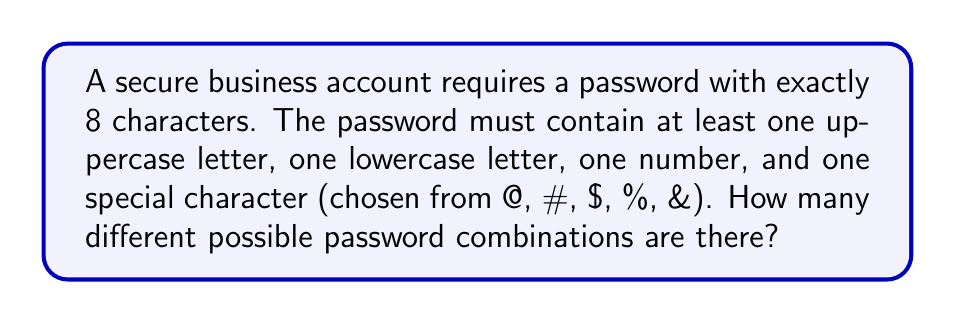Give your solution to this math problem. Let's break this down step-by-step:

1) First, we need to calculate the number of choices for each character:
   - Uppercase letters: 26
   - Lowercase letters: 26
   - Numbers: 10
   - Special characters: 5 (@, #, $, %, &)
   
   Total choices per character: $26 + 26 + 10 + 5 = 67$

2) Now, we need to ensure we have at least one of each required type. We can do this by choosing positions for these required characters:

   $\binom{8}{4} = 70$ ways to choose positions for the required characters

3) For the remaining 4 positions, we can use any of the 67 possible characters.

4) Using the multiplication principle, the total number of possible passwords is:

   $$70 \cdot 26 \cdot 26 \cdot 10 \cdot 5 \cdot 67^4$$

5) Simplifying:
   $$70 \cdot 26 \cdot 26 \cdot 10 \cdot 5 \cdot 67^4 = 32,476,258,575,953,920,000$$

Therefore, there are over 32 quintillion possible password combinations.
Answer: $32,476,258,575,953,920,000$ 